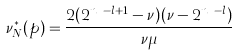<formula> <loc_0><loc_0><loc_500><loc_500>\nu ^ { * } _ { N } ( p ) = \frac { 2 ( 2 ^ { n _ { b } - l + 1 } - \nu ) ( \nu - 2 ^ { n _ { b } - l } ) } { \nu \mu }</formula> 